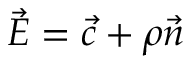<formula> <loc_0><loc_0><loc_500><loc_500>\, { \vec { E } } = { \vec { c } } + \rho { \vec { n } }</formula> 